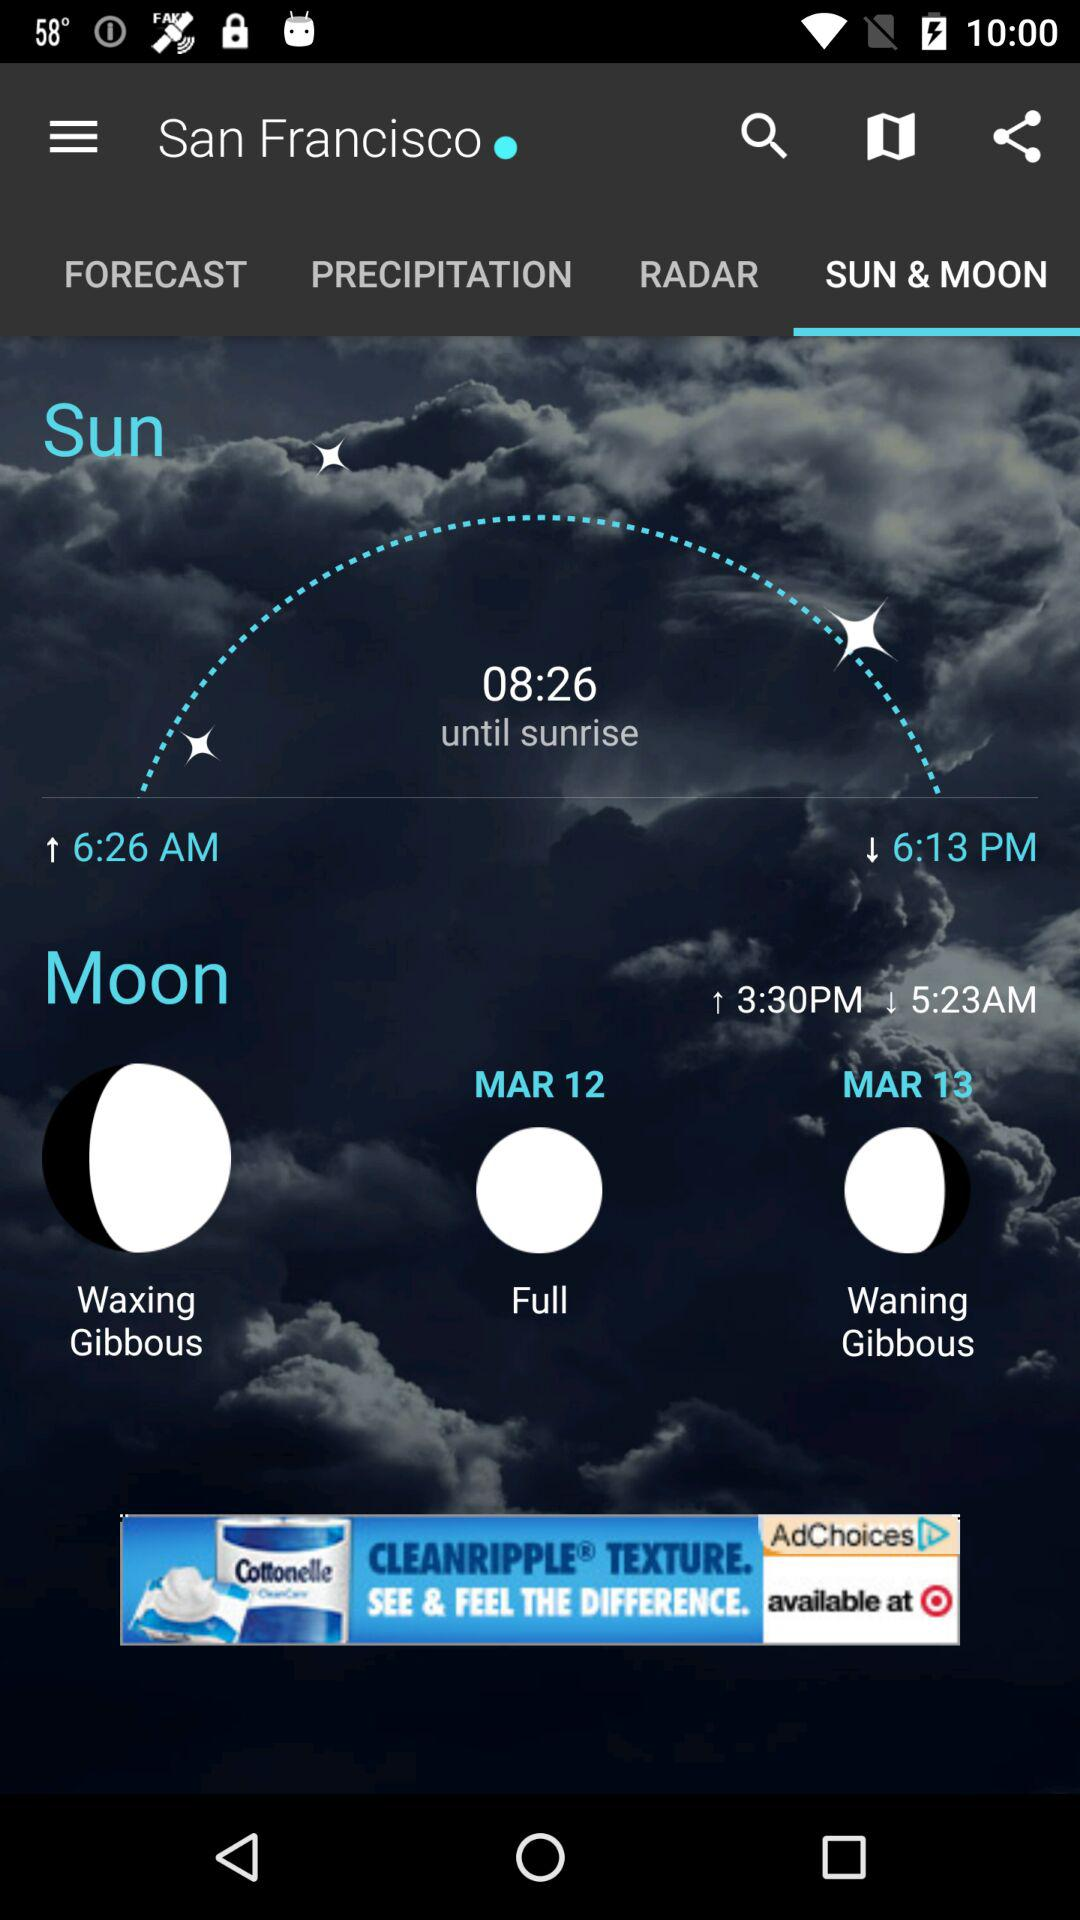How many days before the full moon is the waning gibbous moon?
Answer the question using a single word or phrase. 1 